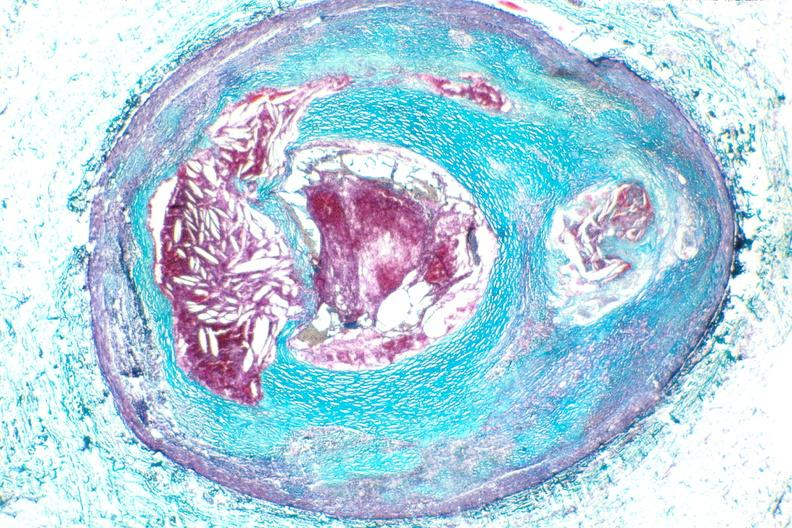s pus in test tube present?
Answer the question using a single word or phrase. No 